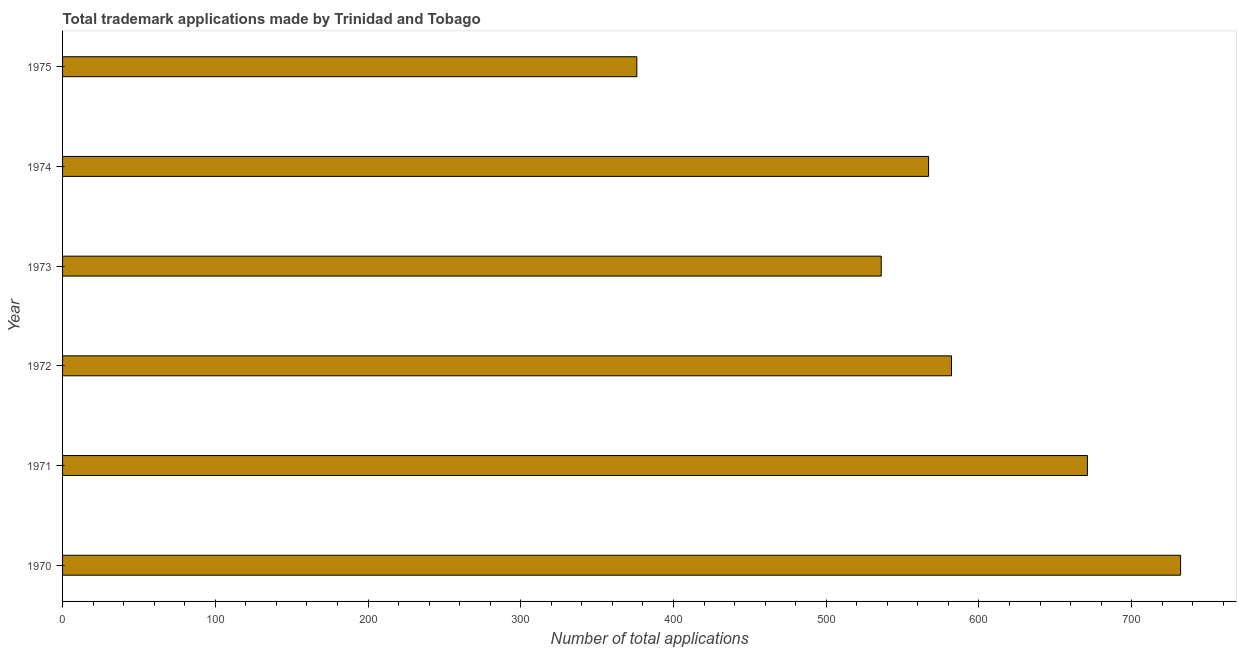Does the graph contain any zero values?
Make the answer very short. No. What is the title of the graph?
Your answer should be compact. Total trademark applications made by Trinidad and Tobago. What is the label or title of the X-axis?
Your answer should be compact. Number of total applications. What is the label or title of the Y-axis?
Your answer should be compact. Year. What is the number of trademark applications in 1973?
Offer a terse response. 536. Across all years, what is the maximum number of trademark applications?
Keep it short and to the point. 732. Across all years, what is the minimum number of trademark applications?
Ensure brevity in your answer.  376. In which year was the number of trademark applications minimum?
Offer a very short reply. 1975. What is the sum of the number of trademark applications?
Ensure brevity in your answer.  3464. What is the difference between the number of trademark applications in 1970 and 1973?
Give a very brief answer. 196. What is the average number of trademark applications per year?
Make the answer very short. 577. What is the median number of trademark applications?
Make the answer very short. 574.5. What is the ratio of the number of trademark applications in 1971 to that in 1975?
Give a very brief answer. 1.78. Is the number of trademark applications in 1970 less than that in 1971?
Keep it short and to the point. No. What is the difference between the highest and the second highest number of trademark applications?
Provide a succinct answer. 61. What is the difference between the highest and the lowest number of trademark applications?
Give a very brief answer. 356. Are all the bars in the graph horizontal?
Your response must be concise. Yes. How many years are there in the graph?
Your answer should be very brief. 6. What is the difference between two consecutive major ticks on the X-axis?
Your answer should be compact. 100. What is the Number of total applications of 1970?
Provide a short and direct response. 732. What is the Number of total applications in 1971?
Your response must be concise. 671. What is the Number of total applications in 1972?
Offer a terse response. 582. What is the Number of total applications in 1973?
Offer a very short reply. 536. What is the Number of total applications of 1974?
Provide a succinct answer. 567. What is the Number of total applications in 1975?
Give a very brief answer. 376. What is the difference between the Number of total applications in 1970 and 1971?
Give a very brief answer. 61. What is the difference between the Number of total applications in 1970 and 1972?
Offer a very short reply. 150. What is the difference between the Number of total applications in 1970 and 1973?
Provide a short and direct response. 196. What is the difference between the Number of total applications in 1970 and 1974?
Ensure brevity in your answer.  165. What is the difference between the Number of total applications in 1970 and 1975?
Offer a terse response. 356. What is the difference between the Number of total applications in 1971 and 1972?
Your answer should be very brief. 89. What is the difference between the Number of total applications in 1971 and 1973?
Your answer should be very brief. 135. What is the difference between the Number of total applications in 1971 and 1974?
Offer a terse response. 104. What is the difference between the Number of total applications in 1971 and 1975?
Keep it short and to the point. 295. What is the difference between the Number of total applications in 1972 and 1973?
Offer a terse response. 46. What is the difference between the Number of total applications in 1972 and 1975?
Your response must be concise. 206. What is the difference between the Number of total applications in 1973 and 1974?
Offer a terse response. -31. What is the difference between the Number of total applications in 1973 and 1975?
Provide a short and direct response. 160. What is the difference between the Number of total applications in 1974 and 1975?
Offer a very short reply. 191. What is the ratio of the Number of total applications in 1970 to that in 1971?
Your answer should be very brief. 1.09. What is the ratio of the Number of total applications in 1970 to that in 1972?
Offer a terse response. 1.26. What is the ratio of the Number of total applications in 1970 to that in 1973?
Keep it short and to the point. 1.37. What is the ratio of the Number of total applications in 1970 to that in 1974?
Provide a succinct answer. 1.29. What is the ratio of the Number of total applications in 1970 to that in 1975?
Your answer should be compact. 1.95. What is the ratio of the Number of total applications in 1971 to that in 1972?
Provide a short and direct response. 1.15. What is the ratio of the Number of total applications in 1971 to that in 1973?
Your response must be concise. 1.25. What is the ratio of the Number of total applications in 1971 to that in 1974?
Offer a terse response. 1.18. What is the ratio of the Number of total applications in 1971 to that in 1975?
Ensure brevity in your answer.  1.78. What is the ratio of the Number of total applications in 1972 to that in 1973?
Ensure brevity in your answer.  1.09. What is the ratio of the Number of total applications in 1972 to that in 1974?
Your response must be concise. 1.03. What is the ratio of the Number of total applications in 1972 to that in 1975?
Your answer should be very brief. 1.55. What is the ratio of the Number of total applications in 1973 to that in 1974?
Provide a short and direct response. 0.94. What is the ratio of the Number of total applications in 1973 to that in 1975?
Provide a succinct answer. 1.43. What is the ratio of the Number of total applications in 1974 to that in 1975?
Ensure brevity in your answer.  1.51. 